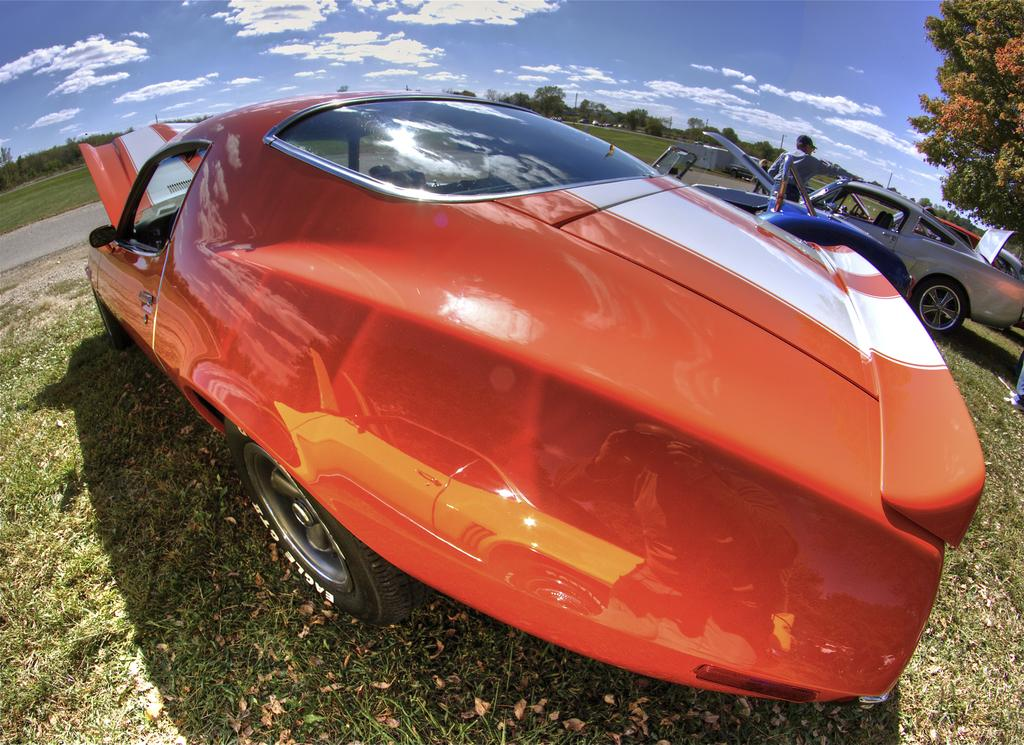What is unusual about the location of the cars in the image? The cars are on the grass in the image. Can you describe the person in the image? There is a person standing in the image. What can be seen in the distance in the image? There are trees in the background of the image. What is visible above the trees in the image? The sky is visible in the background of the image. How many pigs are swimming in the lake in the image? There are no pigs or lake present in the image. What type of brake system is installed on the cars in the image? The image does not provide enough information to determine the type of brake system on the cars. 